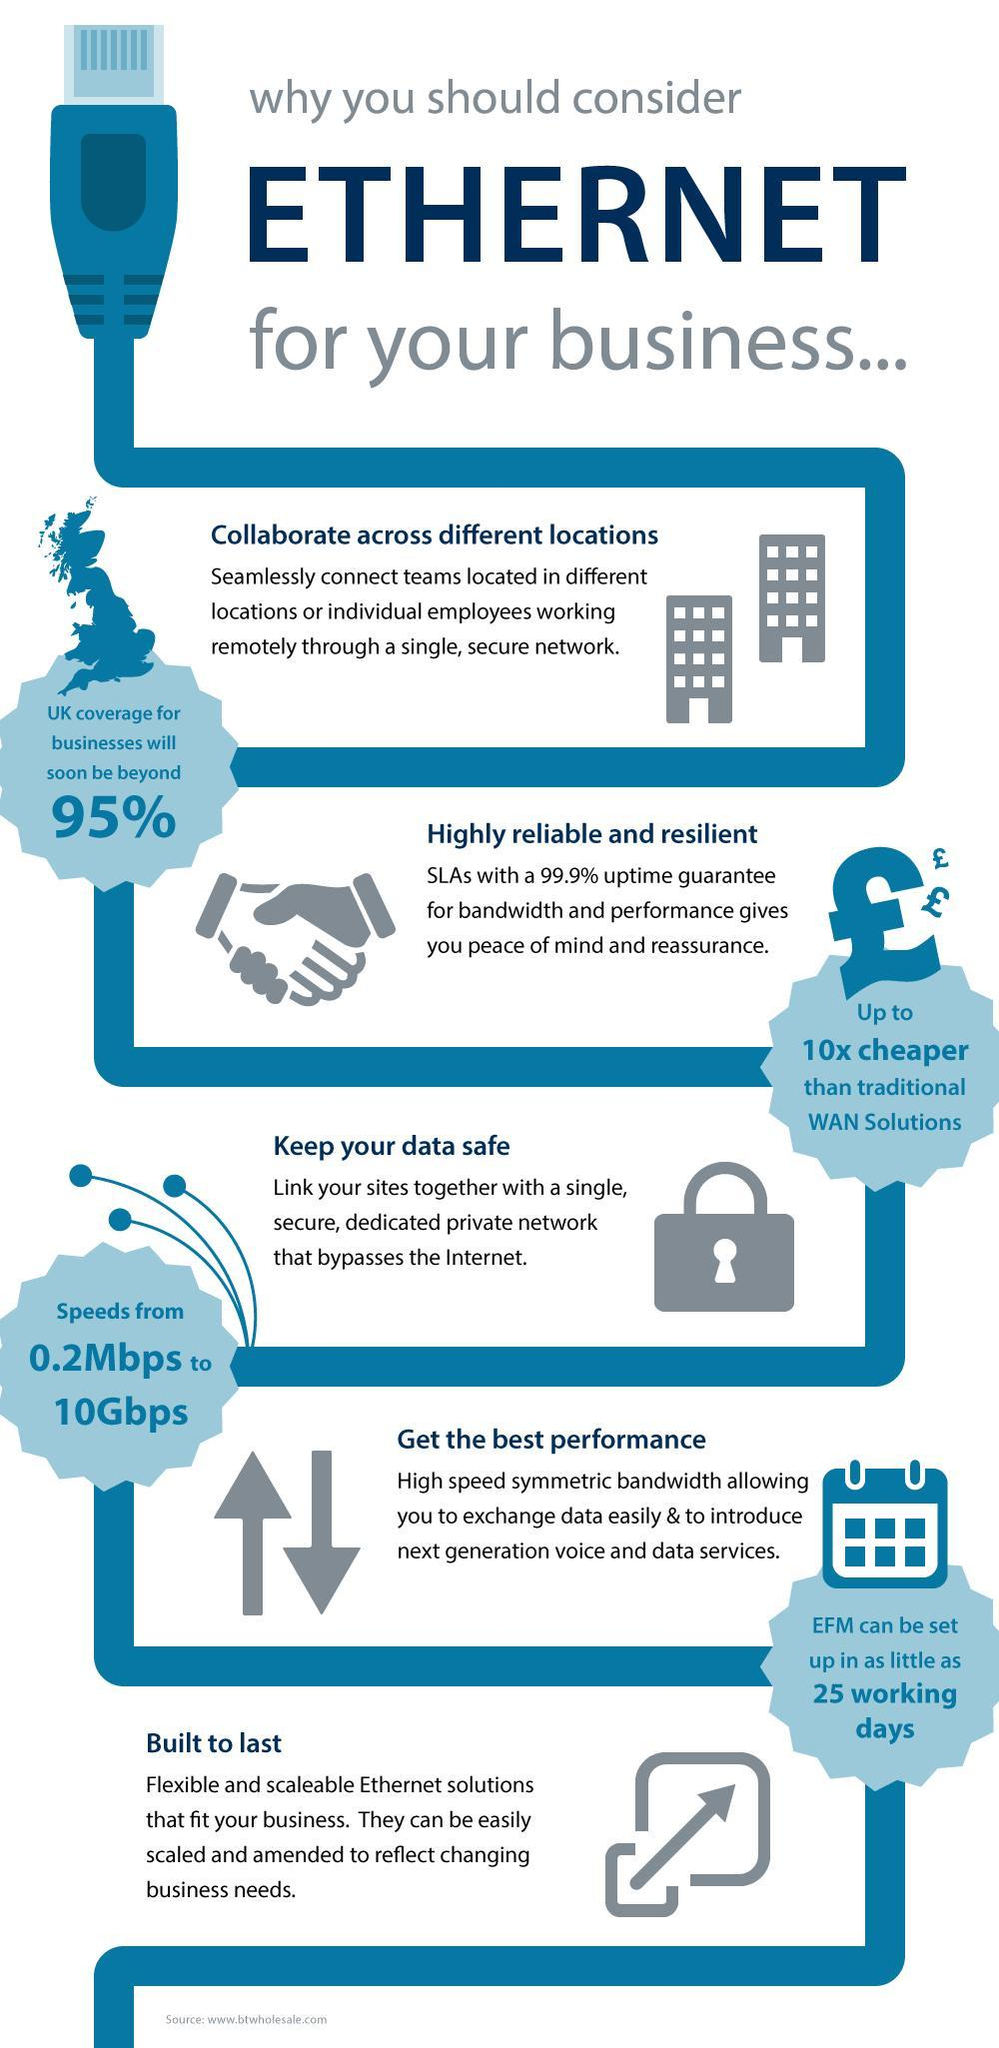How many reasons are listed for considering ethernet for business activities?
Answer the question with a short phrase. 5 